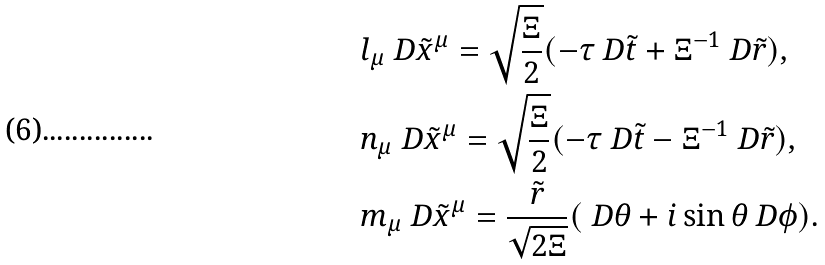Convert formula to latex. <formula><loc_0><loc_0><loc_500><loc_500>& l _ { \mu } \ D \tilde { x } ^ { \mu } = \sqrt { \frac { \Xi } { 2 } } ( - \tau \ D \tilde { t } + \Xi ^ { - 1 } \ D \tilde { r } ) , \\ & n _ { \mu } \ D \tilde { x } ^ { \mu } = \sqrt { \frac { \Xi } { 2 } } ( - \tau \ D \tilde { t } - \Xi ^ { - 1 } \ D \tilde { r } ) , \\ & m _ { \mu } \ D \tilde { x } ^ { \mu } = \frac { \tilde { r } } { \sqrt { 2 \Xi } } ( \ D \theta + i \sin \theta \ D \phi ) .</formula> 